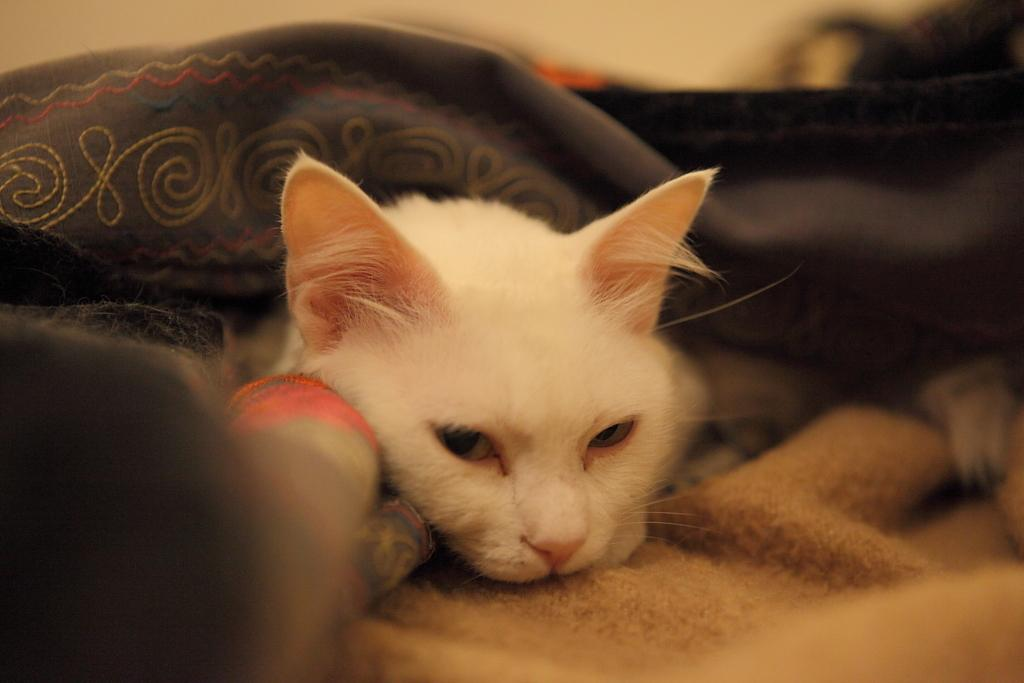What type of animal is in the image? There is a cat in the image. What material is present in the image? There is cloth in the image. Where are the objects located in the image? The objects are on the left side of the image. How would you describe the background of the image? The background of the image is blurred. How does the scarecrow in the image protect the crops from low temperatures? There is no scarecrow present in the image, so it cannot be determined how it would protect crops from low temperatures. 